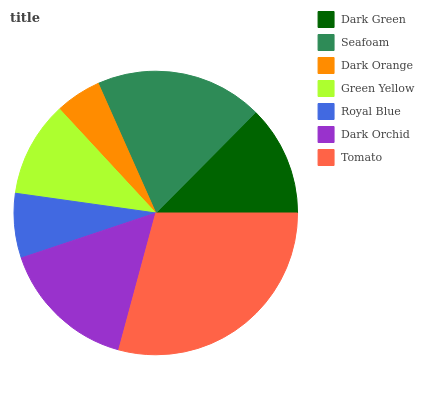Is Dark Orange the minimum?
Answer yes or no. Yes. Is Tomato the maximum?
Answer yes or no. Yes. Is Seafoam the minimum?
Answer yes or no. No. Is Seafoam the maximum?
Answer yes or no. No. Is Seafoam greater than Dark Green?
Answer yes or no. Yes. Is Dark Green less than Seafoam?
Answer yes or no. Yes. Is Dark Green greater than Seafoam?
Answer yes or no. No. Is Seafoam less than Dark Green?
Answer yes or no. No. Is Dark Green the high median?
Answer yes or no. Yes. Is Dark Green the low median?
Answer yes or no. Yes. Is Royal Blue the high median?
Answer yes or no. No. Is Seafoam the low median?
Answer yes or no. No. 